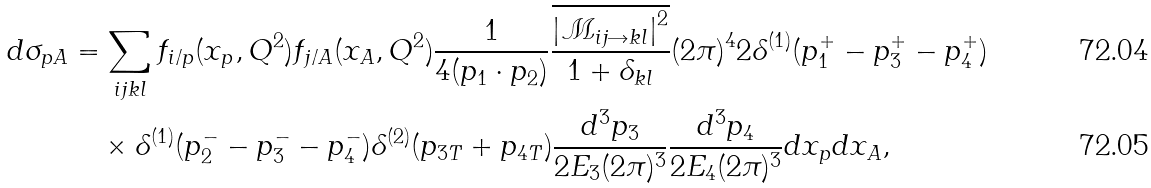Convert formula to latex. <formula><loc_0><loc_0><loc_500><loc_500>d \sigma _ { p A } & = \sum _ { i j k l } f _ { i / p } ( x _ { p } , Q ^ { 2 } ) f _ { j / A } ( x _ { A } , Q ^ { 2 } ) \frac { 1 } { 4 ( p _ { 1 } \cdot p _ { 2 } ) } \frac { \overline { \left | \mathcal { M } _ { i j \rightarrow k l } \right | ^ { 2 } } } { 1 + \delta _ { k l } } ( 2 \pi ) ^ { 4 } 2 \delta ^ { ( 1 ) } ( p _ { 1 } ^ { + } - p _ { 3 } ^ { + } - p _ { 4 } ^ { + } ) \\ & \quad \times \delta ^ { ( 1 ) } ( p _ { 2 } ^ { - } - p _ { 3 } ^ { - } - p _ { 4 } ^ { - } ) \delta ^ { ( 2 ) } ( p _ { 3 T } + p _ { 4 T } ) \frac { d ^ { 3 } p _ { 3 } } { 2 E _ { 3 } ( 2 \pi ) ^ { 3 } } \frac { d ^ { 3 } p _ { 4 } } { 2 E _ { 4 } ( 2 \pi ) ^ { 3 } } d x _ { p } d x _ { A } ,</formula> 